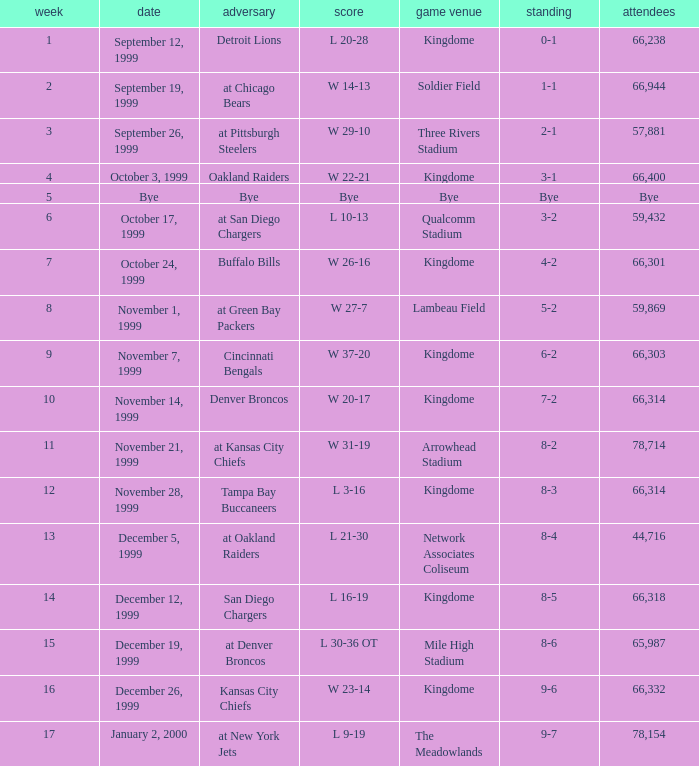For the game that was played on week 2, what is the record? 1-1. 